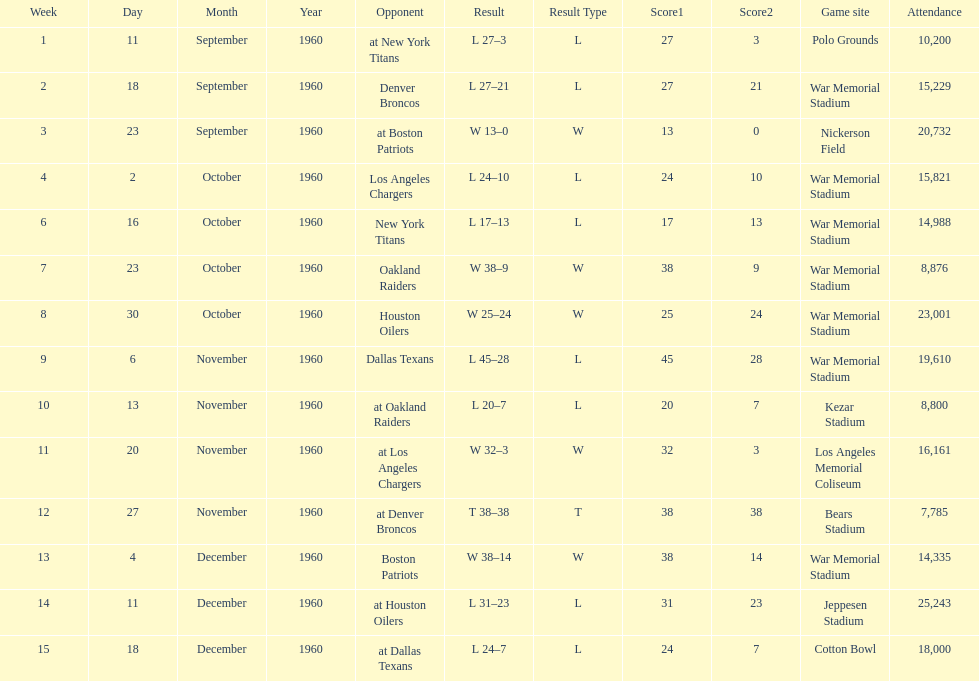What was the largest difference of points in a single game? 29. 